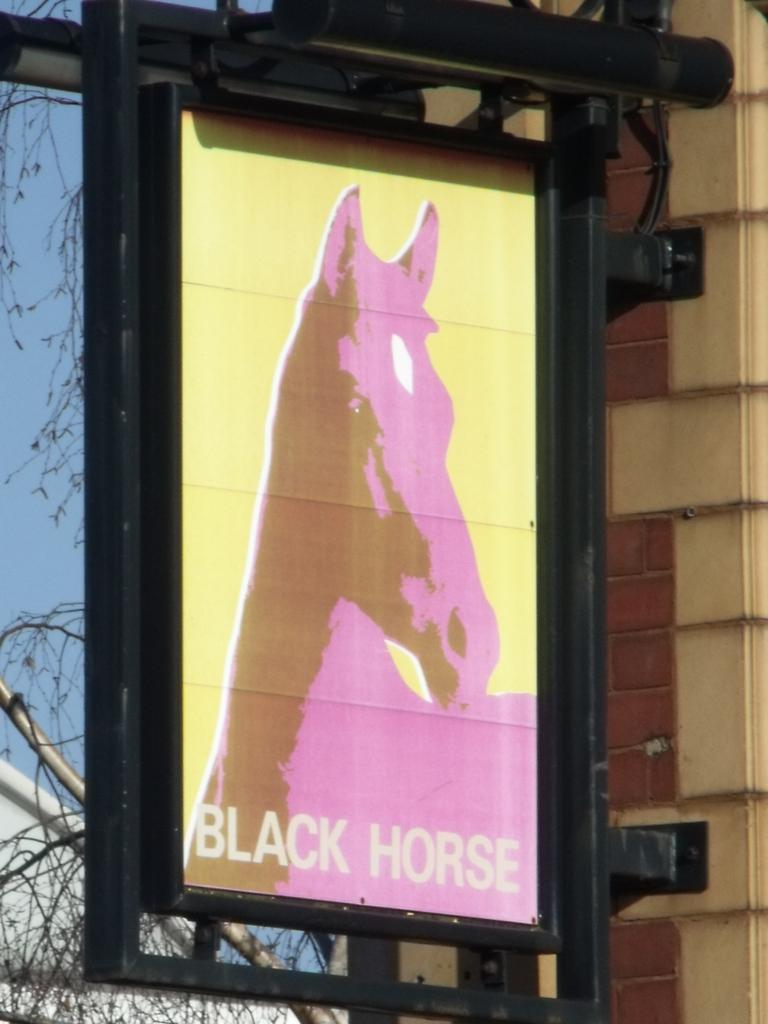What is hanging in the image? There is a banner in the image. What can be seen supporting the banner? There are rods in the image. What is visible in the background of the image? There is a wall, the sky, and tree stems in the background of the image. What type of text is present in the image? There is some text in the image. What image is featured on the banner? There is a horse image in the image. Can you see any sleet falling in the image? There is no mention of sleet or any weather conditions in the image. What type of skirt is hanging on the wall in the image? There is no skirt present in the image; it features a banner with a horse image. 